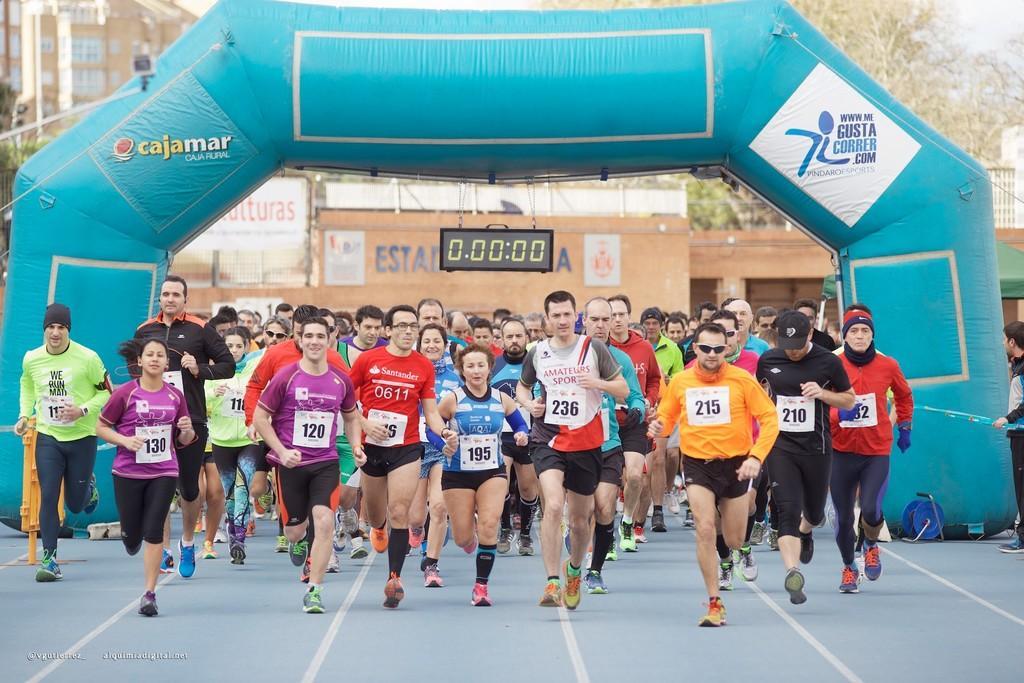Please provide a concise description of this image. In the image there are many people running on the road and behind them there is a balloon arch with a timer hanging to it, this is a marathon, in the background there are trees and buildings. 